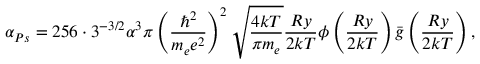Convert formula to latex. <formula><loc_0><loc_0><loc_500><loc_500>\alpha _ { P s } = 2 5 6 \cdot 3 ^ { - 3 / 2 } \alpha ^ { 3 } \pi \left ( \frac { \hbar { ^ } { 2 } } { m _ { e } e ^ { 2 } } \right ) ^ { 2 } \sqrt { \frac { 4 k T } { \pi m _ { e } } } \frac { R y } { 2 k T } \phi \left ( \frac { R y } { 2 k T } \right ) \bar { g } \left ( \frac { R y } { 2 k T } \right ) ,</formula> 